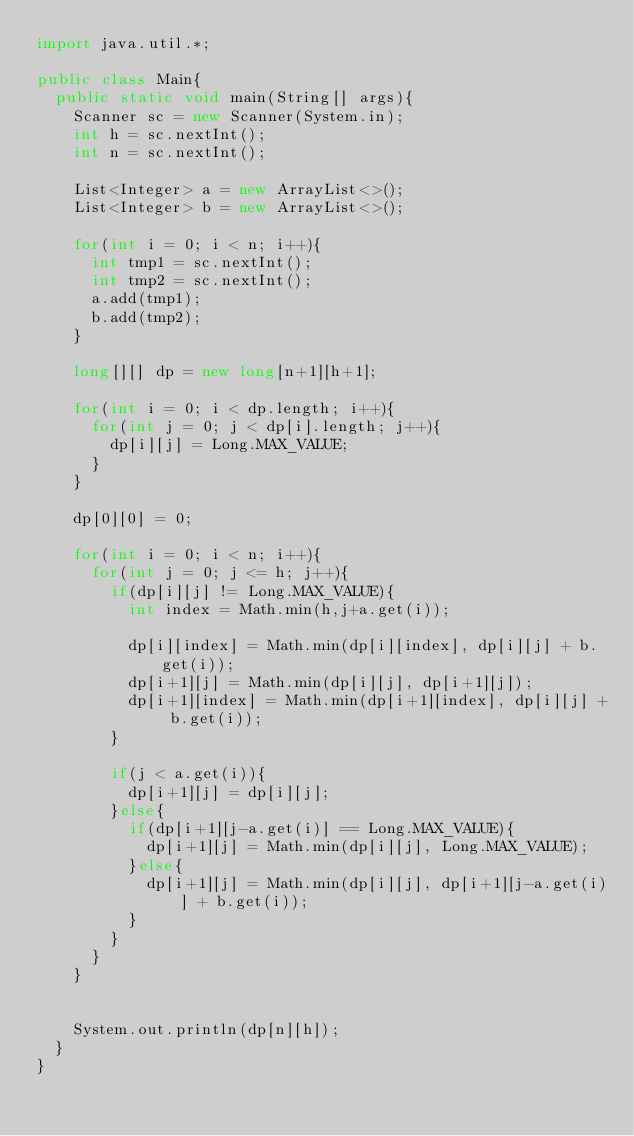Convert code to text. <code><loc_0><loc_0><loc_500><loc_500><_Java_>import java.util.*;

public class Main{
  public static void main(String[] args){
    Scanner sc = new Scanner(System.in);
    int h = sc.nextInt();
    int n = sc.nextInt(); 
    
    List<Integer> a = new ArrayList<>();
    List<Integer> b = new ArrayList<>();
    
    for(int i = 0; i < n; i++){
      int tmp1 = sc.nextInt();
      int tmp2 = sc.nextInt();
      a.add(tmp1);
      b.add(tmp2);
    }
    
    long[][] dp = new long[n+1][h+1];
    
    for(int i = 0; i < dp.length; i++){
      for(int j = 0; j < dp[i].length; j++){
        dp[i][j] = Long.MAX_VALUE;
      }
    }
    
    dp[0][0] = 0;
    
    for(int i = 0; i < n; i++){
      for(int j = 0; j <= h; j++){
        if(dp[i][j] != Long.MAX_VALUE){
          int index = Math.min(h,j+a.get(i));
          
          dp[i][index] = Math.min(dp[i][index], dp[i][j] + b.get(i));
          dp[i+1][j] = Math.min(dp[i][j], dp[i+1][j]);
          dp[i+1][index] = Math.min(dp[i+1][index], dp[i][j] + b.get(i));
        }
        
        if(j < a.get(i)){
          dp[i+1][j] = dp[i][j];
        }else{
          if(dp[i+1][j-a.get(i)] == Long.MAX_VALUE){
            dp[i+1][j] = Math.min(dp[i][j], Long.MAX_VALUE);
          }else{
            dp[i+1][j] = Math.min(dp[i][j], dp[i+1][j-a.get(i)] + b.get(i));
          }
        }
      }
    }
    

    System.out.println(dp[n][h]);
  }
}</code> 